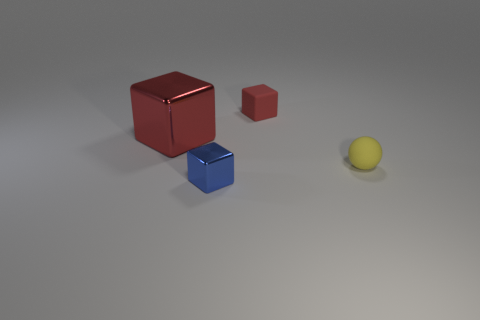The small thing that is the same color as the big shiny object is what shape?
Provide a short and direct response. Cube. There is another tiny red object that is the same shape as the tiny shiny thing; what is it made of?
Keep it short and to the point. Rubber. What is the shape of the object that is both behind the yellow sphere and right of the large red block?
Keep it short and to the point. Cube. How many objects are blue blocks or objects that are left of the matte block?
Provide a short and direct response. 2. Is the sphere made of the same material as the big block?
Offer a terse response. No. What number of other things are the same shape as the blue object?
Ensure brevity in your answer.  2. There is a object that is on the left side of the tiny red cube and behind the small yellow object; how big is it?
Provide a short and direct response. Large. What number of rubber objects are either large purple balls or tiny red objects?
Keep it short and to the point. 1. Is the shape of the red thing that is behind the large red shiny object the same as the metal thing in front of the big cube?
Provide a succinct answer. Yes. Are there any blue cubes that have the same material as the large object?
Your answer should be very brief. Yes. 